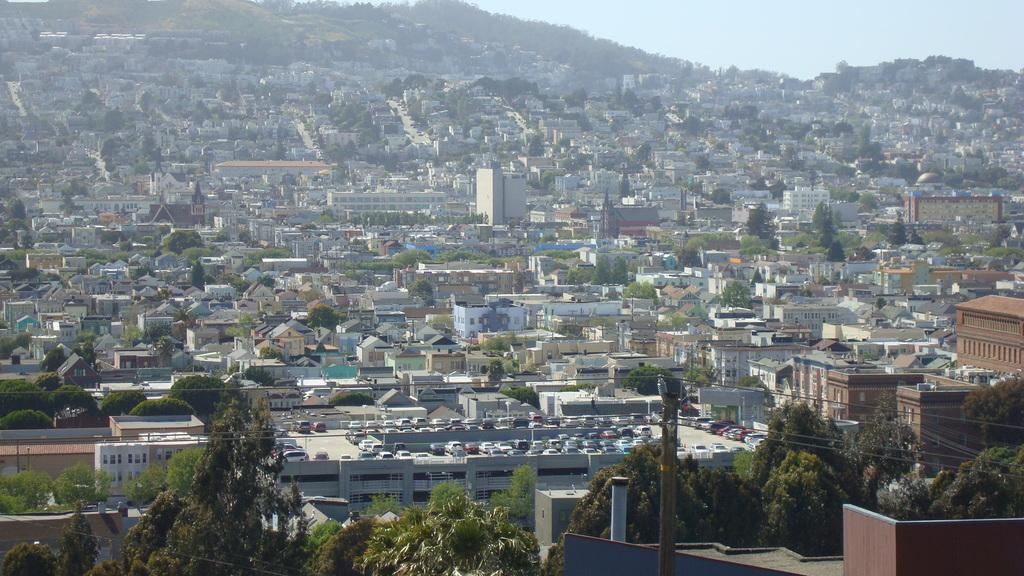What type of structures can be seen in the image? There are buildings in the image. What other natural elements are present in the image? There are trees in the image. What utility infrastructure is visible in the image? There is a current pole with wires in the image. Where are the cars located in the image? The cars are parked in a parking area in the image. What can be seen in the background of the image? The sky is visible in the background of the image. How does the current pole breathe in the image? The current pole does not breathe in the image; it is an inanimate object. What type of food can be seen being cooked in the image? There is no food being cooked in the image. 